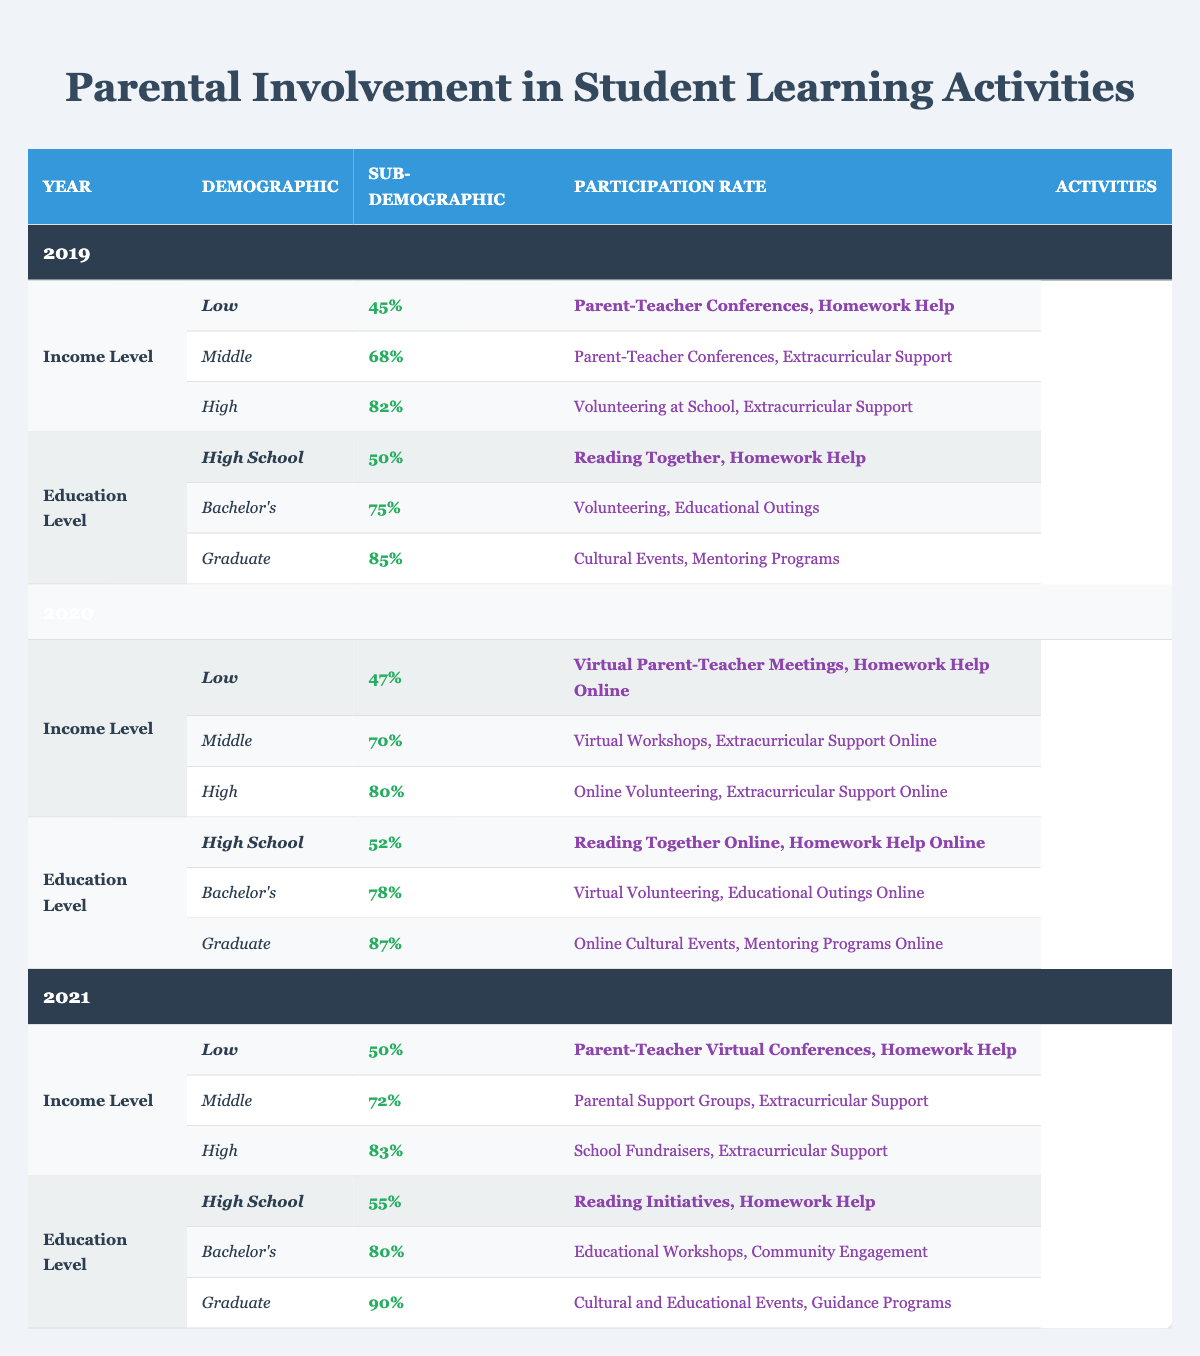What was the participation rate for parents with a Low income level in 2021? Referring to the table under the year 2021 and the Income Level demographic, the participation rate for Low income level is 50%.
Answer: 50% Which demographic group had the highest participation rate in 2020? In 2020, the highest participation rate can be found by comparing the rates for Low, Middle, and High income levels as well as for High School, Bachelor's, and Graduate education levels. The highest is for Graduate education level with 87%.
Answer: Graduate How many activities were reported for parents with a High education level in 2019? Under the Education Level demographic in 2019, the High education level (Graduate) listed two activities: Cultural Events and Mentoring Programs. Therefore, there are 2 activities reported.
Answer: 2 Did the participation rate for Middle income level parents increase from 2019 to 2021? The participation rates for Middle income level are 68% in 2019, 72% in 2021. Since 72% is greater than 68%, it indicates an increase.
Answer: Yes What is the average participation rate for parents with a High education level over the three years? To find the average, we add the participation rates for High education level across the years: 85% (2019) + 87% (2020) + 90% (2021) = 262%. There are 3 years, so we divide 262% by 3, which gives us approximately 87.33%.
Answer: 87.33% What activities were engaged by Middle income level parents in 2020? In 2020 under the Middle income level, the activities listed are Virtual Workshops and Extracurricular Support Online.
Answer: Virtual Workshops, Extracurricular Support Online Was the participation rate for parents with a High income level lower in 2019 than in 2020? Checking the rates, High income level parents had a participation rate of 82% in 2019 and 80% in 2020, which shows that the rate in 2020 is indeed lower.
Answer: Yes What is the difference in participation rates for parents with a Low income level between 2019 and 2021? The participation rates for Low income level are 45% in 2019 and 50% in 2021. Therefore, the difference is 50% - 45% = 5%.
Answer: 5% 